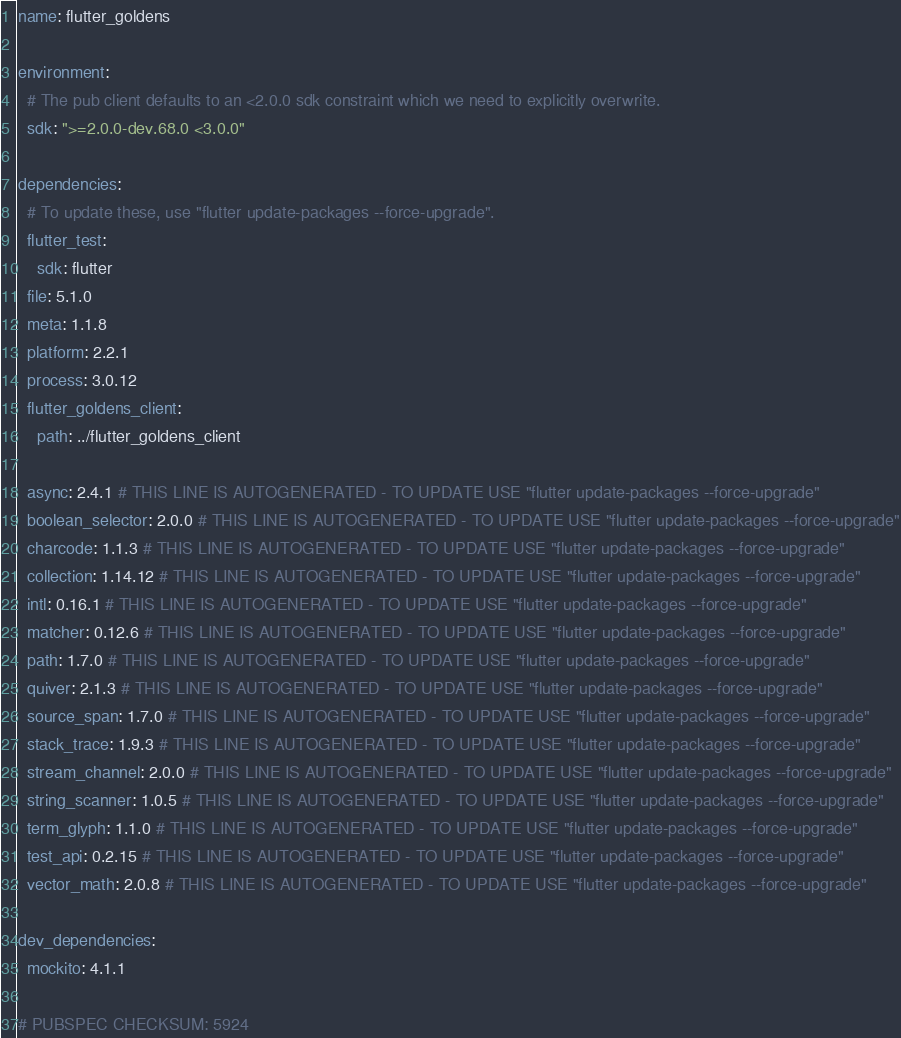<code> <loc_0><loc_0><loc_500><loc_500><_YAML_>name: flutter_goldens

environment:
  # The pub client defaults to an <2.0.0 sdk constraint which we need to explicitly overwrite.
  sdk: ">=2.0.0-dev.68.0 <3.0.0"

dependencies:
  # To update these, use "flutter update-packages --force-upgrade".
  flutter_test:
    sdk: flutter
  file: 5.1.0
  meta: 1.1.8
  platform: 2.2.1
  process: 3.0.12
  flutter_goldens_client:
    path: ../flutter_goldens_client

  async: 2.4.1 # THIS LINE IS AUTOGENERATED - TO UPDATE USE "flutter update-packages --force-upgrade"
  boolean_selector: 2.0.0 # THIS LINE IS AUTOGENERATED - TO UPDATE USE "flutter update-packages --force-upgrade"
  charcode: 1.1.3 # THIS LINE IS AUTOGENERATED - TO UPDATE USE "flutter update-packages --force-upgrade"
  collection: 1.14.12 # THIS LINE IS AUTOGENERATED - TO UPDATE USE "flutter update-packages --force-upgrade"
  intl: 0.16.1 # THIS LINE IS AUTOGENERATED - TO UPDATE USE "flutter update-packages --force-upgrade"
  matcher: 0.12.6 # THIS LINE IS AUTOGENERATED - TO UPDATE USE "flutter update-packages --force-upgrade"
  path: 1.7.0 # THIS LINE IS AUTOGENERATED - TO UPDATE USE "flutter update-packages --force-upgrade"
  quiver: 2.1.3 # THIS LINE IS AUTOGENERATED - TO UPDATE USE "flutter update-packages --force-upgrade"
  source_span: 1.7.0 # THIS LINE IS AUTOGENERATED - TO UPDATE USE "flutter update-packages --force-upgrade"
  stack_trace: 1.9.3 # THIS LINE IS AUTOGENERATED - TO UPDATE USE "flutter update-packages --force-upgrade"
  stream_channel: 2.0.0 # THIS LINE IS AUTOGENERATED - TO UPDATE USE "flutter update-packages --force-upgrade"
  string_scanner: 1.0.5 # THIS LINE IS AUTOGENERATED - TO UPDATE USE "flutter update-packages --force-upgrade"
  term_glyph: 1.1.0 # THIS LINE IS AUTOGENERATED - TO UPDATE USE "flutter update-packages --force-upgrade"
  test_api: 0.2.15 # THIS LINE IS AUTOGENERATED - TO UPDATE USE "flutter update-packages --force-upgrade"
  vector_math: 2.0.8 # THIS LINE IS AUTOGENERATED - TO UPDATE USE "flutter update-packages --force-upgrade"

dev_dependencies:
  mockito: 4.1.1

# PUBSPEC CHECKSUM: 5924
</code> 